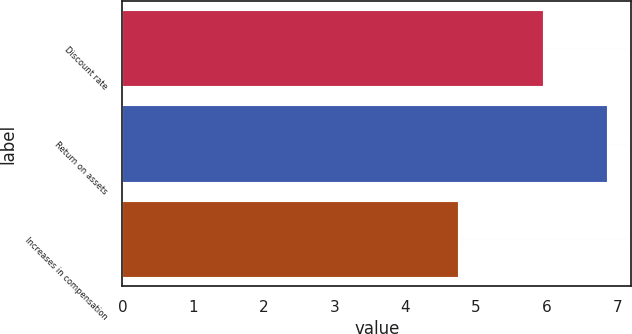Convert chart. <chart><loc_0><loc_0><loc_500><loc_500><bar_chart><fcel>Discount rate<fcel>Return on assets<fcel>Increases in compensation<nl><fcel>5.95<fcel>6.86<fcel>4.75<nl></chart> 